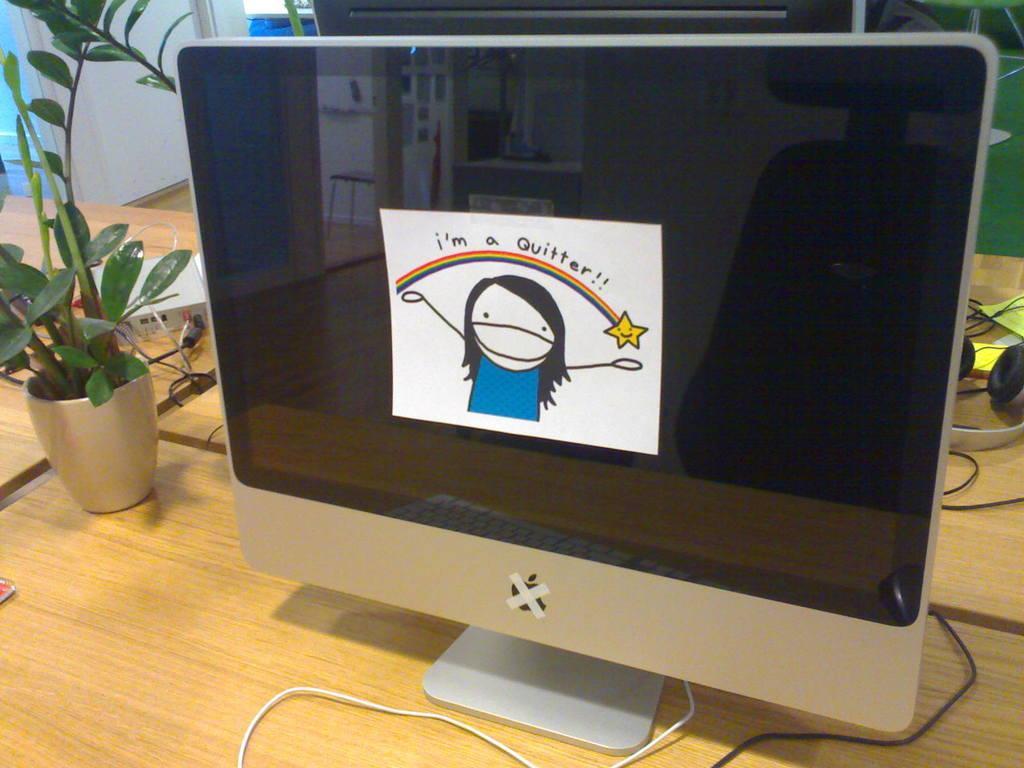Please provide a concise description of this image. In the center of the image there is a monitor screen. There is a plant on the table. 